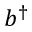<formula> <loc_0><loc_0><loc_500><loc_500>b ^ { \dagger }</formula> 